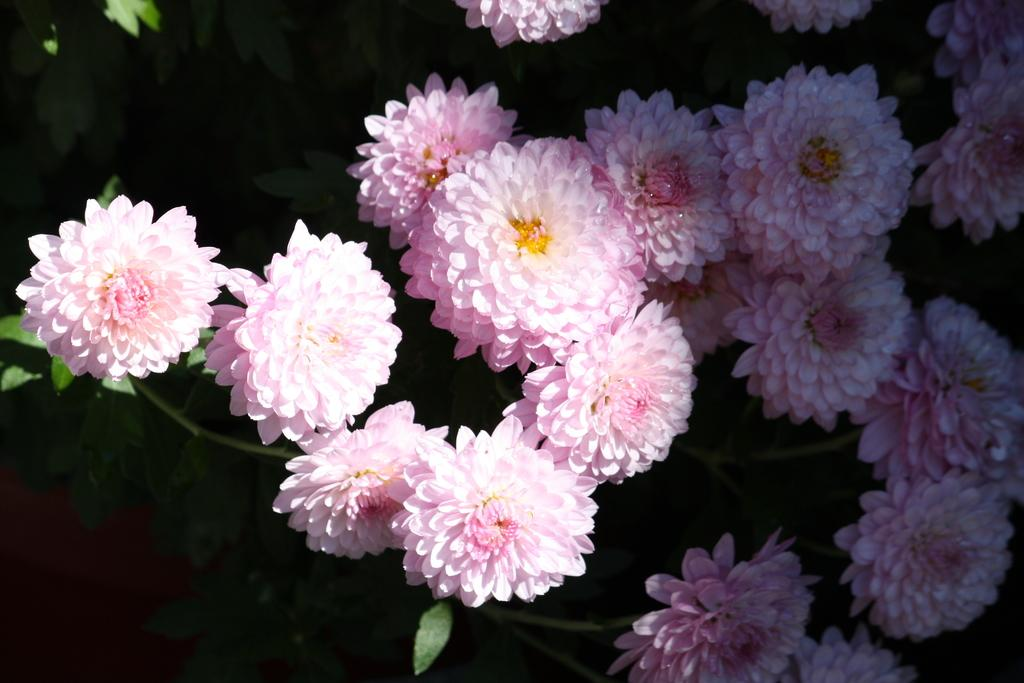What type of plant is present in the image? There are flowers in the image. What color are the petals of the flowers? The flowers have pink color petals. What else can be seen in the background of the image? There are leafs in the background of the image. How would you describe the overall lighting or color scheme of the image? The rest of the image is dark. What type of haircut does the flower have in the image? There is no haircut present in the image, as flowers do not have hair. 